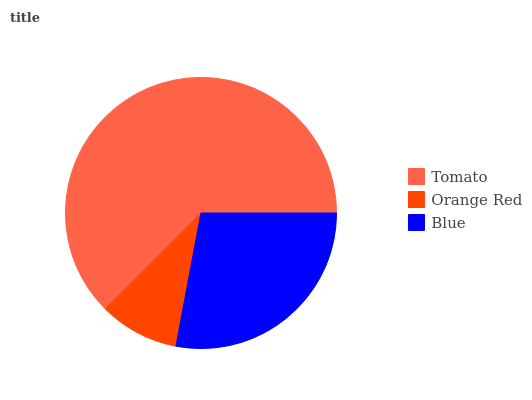Is Orange Red the minimum?
Answer yes or no. Yes. Is Tomato the maximum?
Answer yes or no. Yes. Is Blue the minimum?
Answer yes or no. No. Is Blue the maximum?
Answer yes or no. No. Is Blue greater than Orange Red?
Answer yes or no. Yes. Is Orange Red less than Blue?
Answer yes or no. Yes. Is Orange Red greater than Blue?
Answer yes or no. No. Is Blue less than Orange Red?
Answer yes or no. No. Is Blue the high median?
Answer yes or no. Yes. Is Blue the low median?
Answer yes or no. Yes. Is Orange Red the high median?
Answer yes or no. No. Is Orange Red the low median?
Answer yes or no. No. 